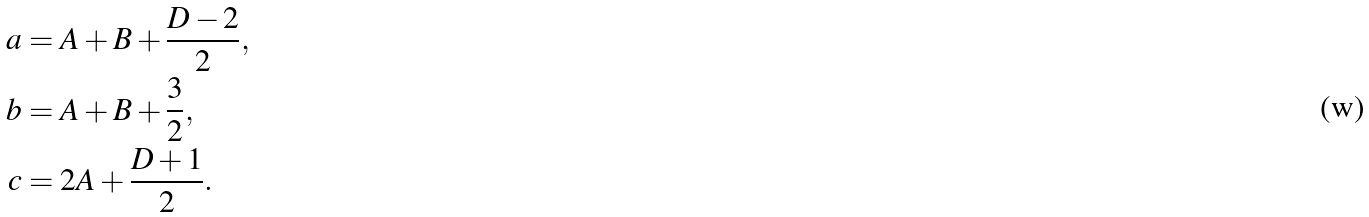Convert formula to latex. <formula><loc_0><loc_0><loc_500><loc_500>a & = A + B + \frac { D - 2 } { 2 } , \\ b & = A + B + \frac { 3 } { 2 } , \\ c & = 2 A + \frac { D + 1 } { 2 } .</formula> 